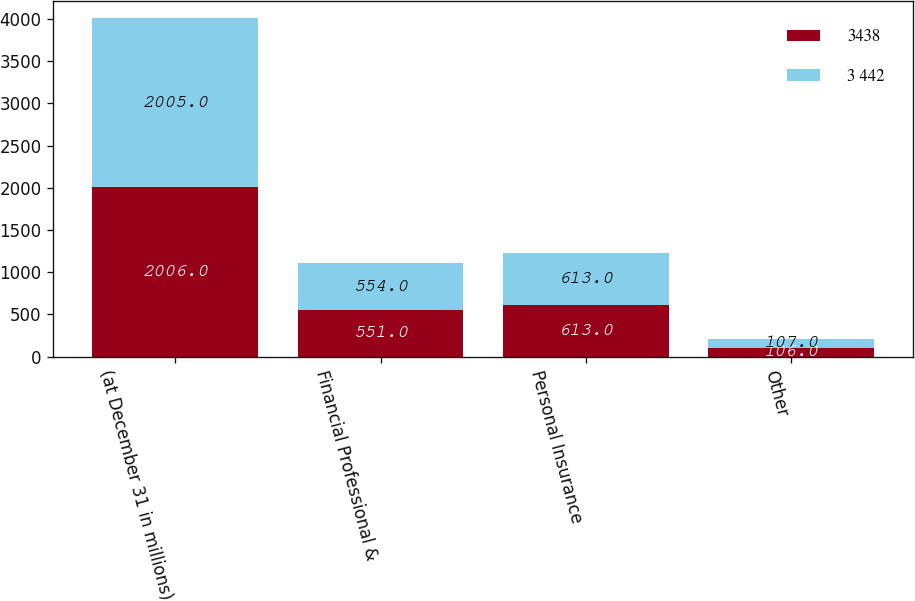Convert chart. <chart><loc_0><loc_0><loc_500><loc_500><stacked_bar_chart><ecel><fcel>(at December 31 in millions)<fcel>Financial Professional &<fcel>Personal Insurance<fcel>Other<nl><fcel>3438<fcel>2006<fcel>551<fcel>613<fcel>106<nl><fcel>3 442<fcel>2005<fcel>554<fcel>613<fcel>107<nl></chart> 